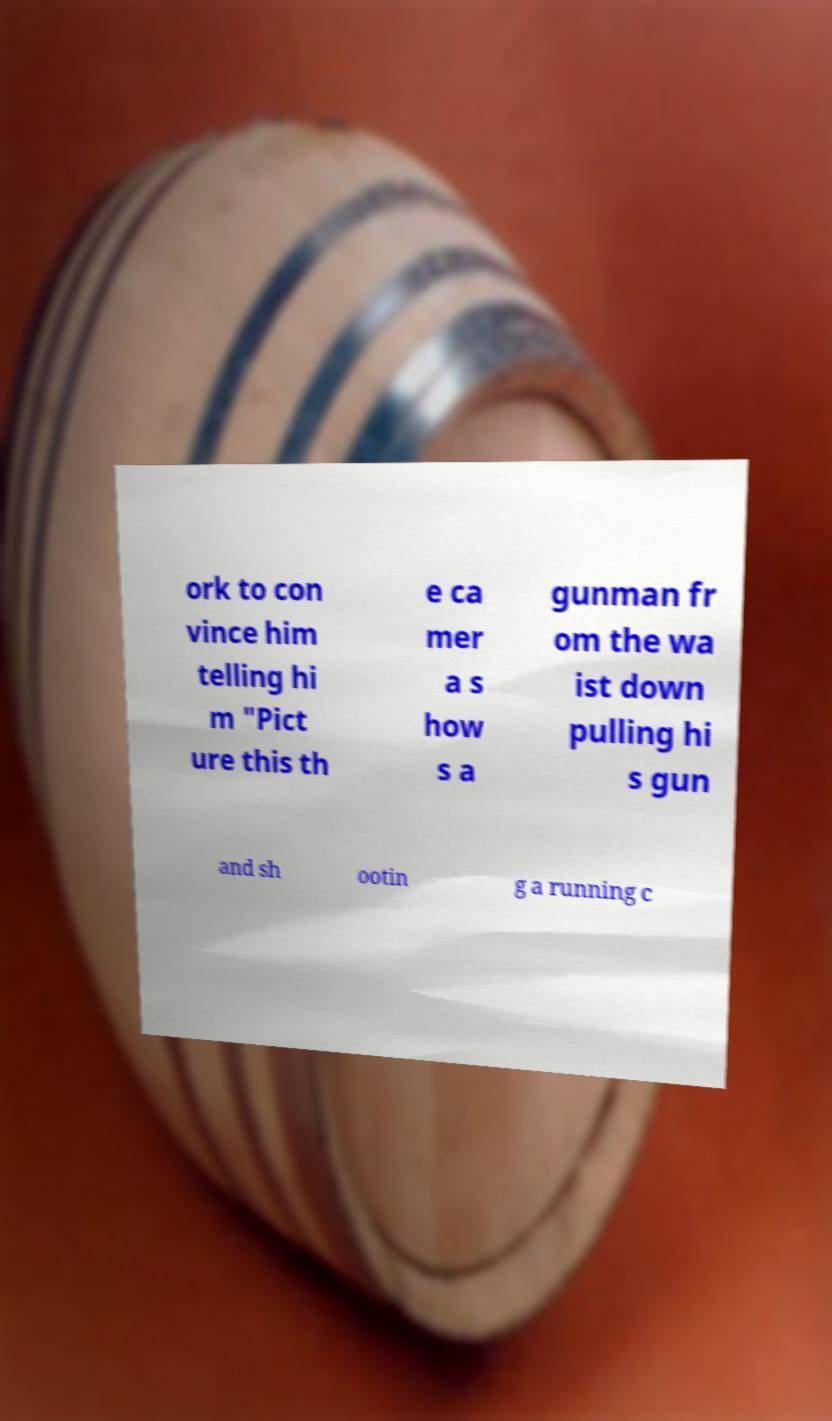Can you accurately transcribe the text from the provided image for me? ork to con vince him telling hi m "Pict ure this th e ca mer a s how s a gunman fr om the wa ist down pulling hi s gun and sh ootin g a running c 